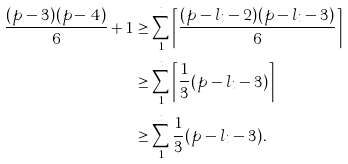<formula> <loc_0><loc_0><loc_500><loc_500>\frac { ( p - 3 ) ( p - 4 ) } { 6 } + 1 & \geq \sum _ { 1 } ^ { t } \left \lceil \frac { ( p - l _ { i } - 2 ) ( p - l _ { i } - 3 ) } { 6 } \right \rceil \\ & \geq \sum _ { 1 } ^ { t } \left \lceil \frac { 1 } { 3 } ( p - l _ { i } - 3 ) \right \rceil \\ & \geq \sum _ { 1 } ^ { t } \frac { 1 } { 3 } ( p - l _ { i } - 3 ) .</formula> 